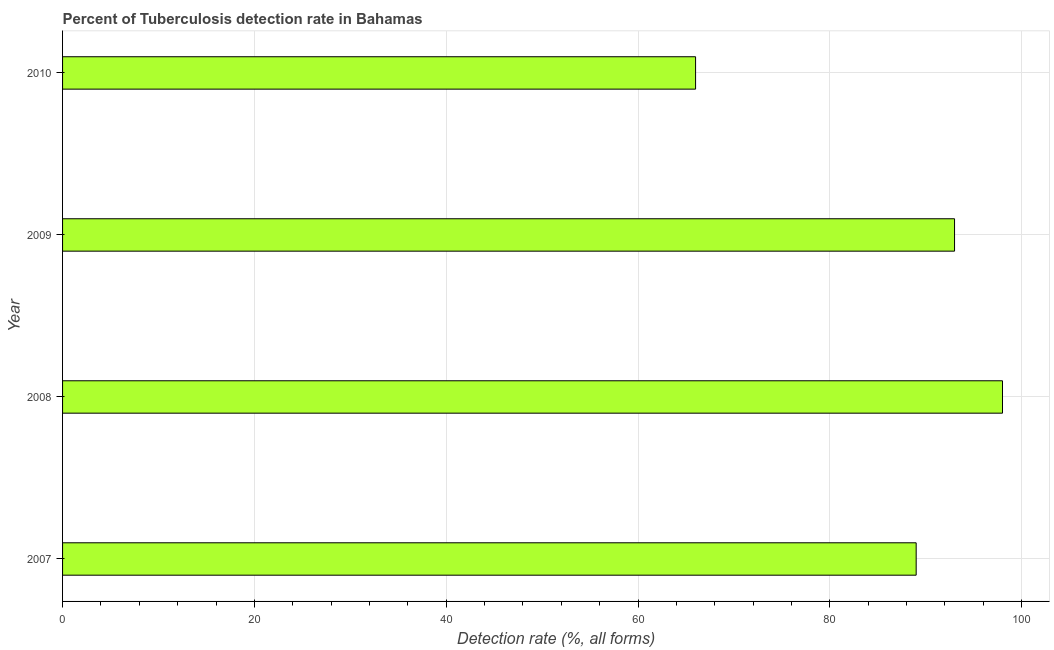Does the graph contain any zero values?
Your answer should be very brief. No. What is the title of the graph?
Your response must be concise. Percent of Tuberculosis detection rate in Bahamas. What is the label or title of the X-axis?
Provide a succinct answer. Detection rate (%, all forms). What is the label or title of the Y-axis?
Provide a short and direct response. Year. What is the detection rate of tuberculosis in 2010?
Ensure brevity in your answer.  66. Across all years, what is the maximum detection rate of tuberculosis?
Your answer should be compact. 98. Across all years, what is the minimum detection rate of tuberculosis?
Your answer should be very brief. 66. In which year was the detection rate of tuberculosis minimum?
Offer a very short reply. 2010. What is the sum of the detection rate of tuberculosis?
Make the answer very short. 346. What is the difference between the detection rate of tuberculosis in 2008 and 2009?
Ensure brevity in your answer.  5. What is the median detection rate of tuberculosis?
Offer a terse response. 91. What is the ratio of the detection rate of tuberculosis in 2007 to that in 2010?
Offer a terse response. 1.35. Is the detection rate of tuberculosis in 2008 less than that in 2009?
Your answer should be compact. No. Is the difference between the detection rate of tuberculosis in 2007 and 2010 greater than the difference between any two years?
Offer a very short reply. No. How many years are there in the graph?
Make the answer very short. 4. What is the Detection rate (%, all forms) of 2007?
Keep it short and to the point. 89. What is the Detection rate (%, all forms) in 2009?
Give a very brief answer. 93. What is the difference between the Detection rate (%, all forms) in 2008 and 2009?
Provide a short and direct response. 5. What is the difference between the Detection rate (%, all forms) in 2008 and 2010?
Your response must be concise. 32. What is the ratio of the Detection rate (%, all forms) in 2007 to that in 2008?
Offer a terse response. 0.91. What is the ratio of the Detection rate (%, all forms) in 2007 to that in 2010?
Make the answer very short. 1.35. What is the ratio of the Detection rate (%, all forms) in 2008 to that in 2009?
Keep it short and to the point. 1.05. What is the ratio of the Detection rate (%, all forms) in 2008 to that in 2010?
Make the answer very short. 1.49. What is the ratio of the Detection rate (%, all forms) in 2009 to that in 2010?
Keep it short and to the point. 1.41. 